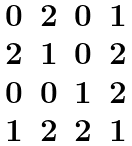<formula> <loc_0><loc_0><loc_500><loc_500>\begin{matrix} 0 & 2 & 0 & 1 \\ 2 & 1 & 0 & 2 \\ 0 & 0 & 1 & 2 \\ 1 & 2 & 2 & 1 \end{matrix}</formula> 